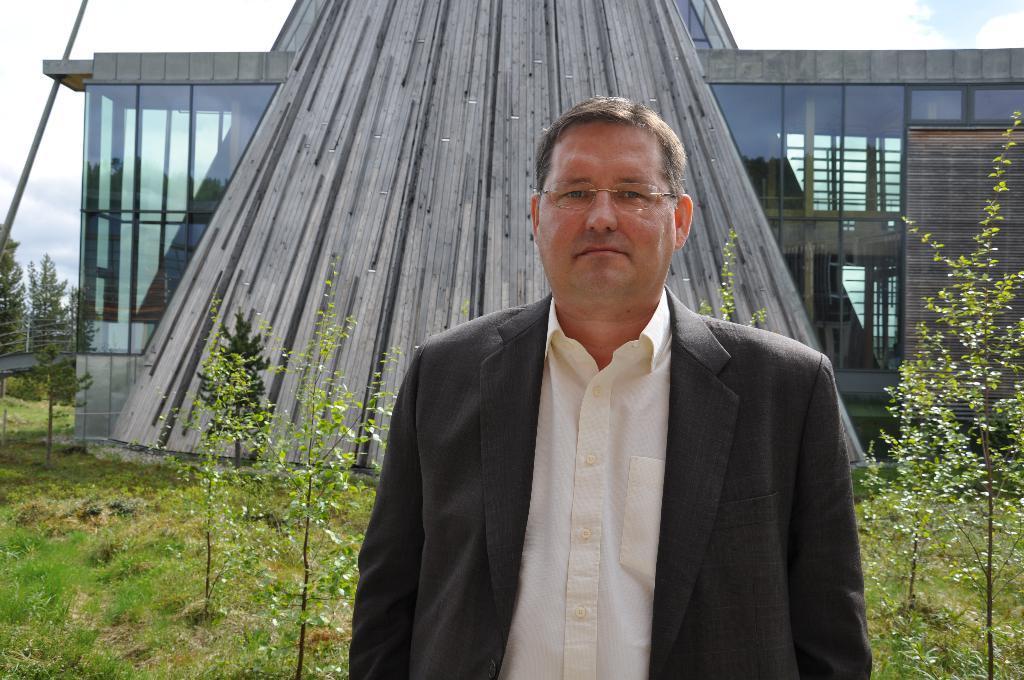In one or two sentences, can you explain what this image depicts? In this image there is a person standing wearing suit and glasses, in the background there are plants and an architecture. 